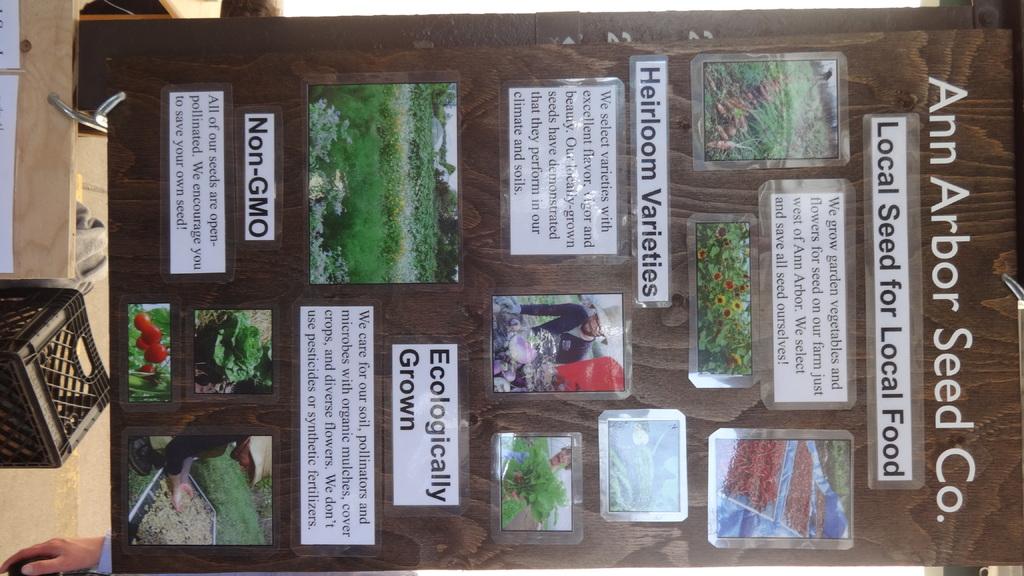What is the name of the seed company?
Ensure brevity in your answer.  Ann arbor. What is the local seed for?
Ensure brevity in your answer.  Local food. 